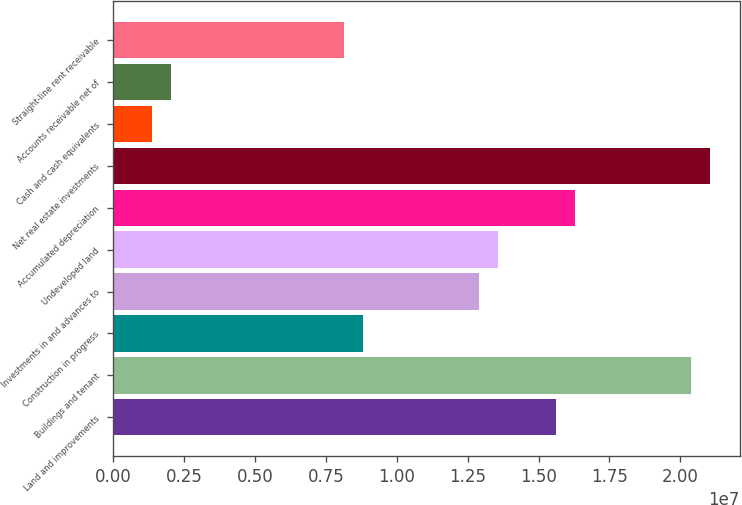Convert chart. <chart><loc_0><loc_0><loc_500><loc_500><bar_chart><fcel>Land and improvements<fcel>Buildings and tenant<fcel>Construction in progress<fcel>Investments in and advances to<fcel>Undeveloped land<fcel>Accumulated depreciation<fcel>Net real estate investments<fcel>Cash and cash equivalents<fcel>Accounts receivable net of<fcel>Straight-line rent receivable<nl><fcel>1.56151e+07<fcel>2.03671e+07<fcel>8.82658e+06<fcel>1.28997e+07<fcel>1.35786e+07<fcel>1.6294e+07<fcel>2.1046e+07<fcel>1.35919e+06<fcel>2.03805e+06<fcel>8.14773e+06<nl></chart> 